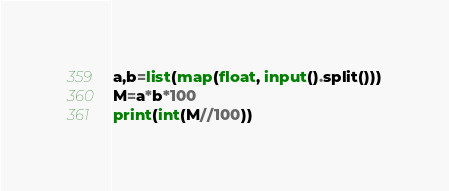<code> <loc_0><loc_0><loc_500><loc_500><_Python_>a,b=list(map(float, input().split()))
M=a*b*100
print(int(M//100))
</code> 